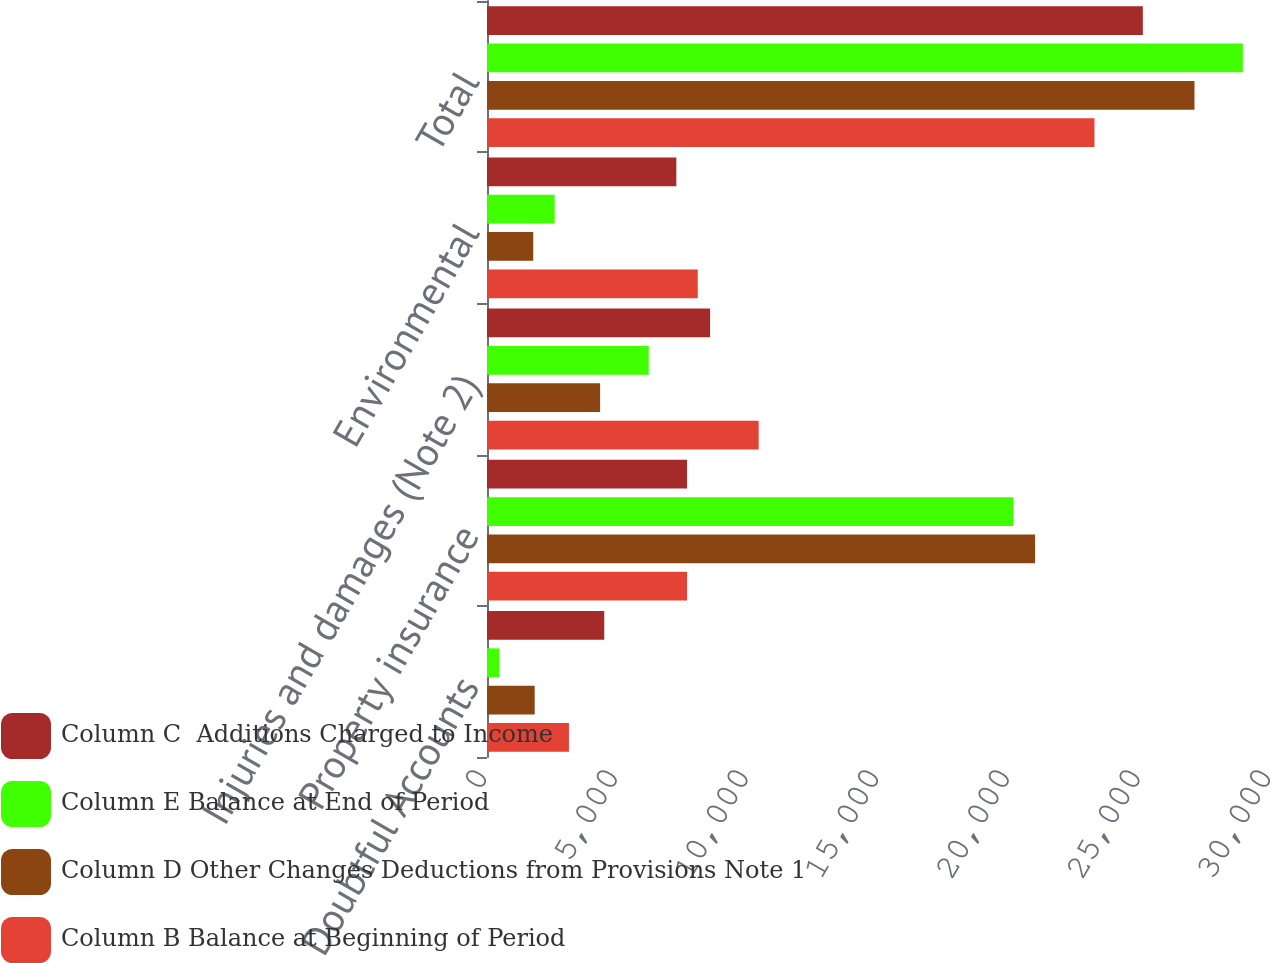<chart> <loc_0><loc_0><loc_500><loc_500><stacked_bar_chart><ecel><fcel>Doubtful Accounts<fcel>Property insurance<fcel>Injuries and damages (Note 2)<fcel>Environmental<fcel>Total<nl><fcel>Column C  Additions Charged to Income<fcel>4487<fcel>7654.5<fcel>8537<fcel>7245<fcel>25096<nl><fcel>Column E Balance at End of Period<fcel>473<fcel>20146<fcel>6188<fcel>2589<fcel>28923<nl><fcel>Column D Other Changes Deductions from Provisions Note 1<fcel>1825<fcel>20973<fcel>4329<fcel>1770<fcel>27072<nl><fcel>Column B Balance at Beginning of Period<fcel>3135<fcel>7654.5<fcel>10396<fcel>8064<fcel>23245<nl></chart> 